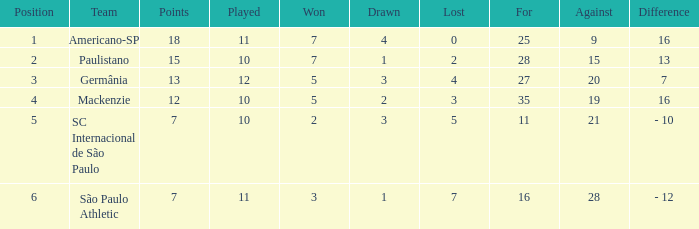Identify the points for paulistano. 15.0. 